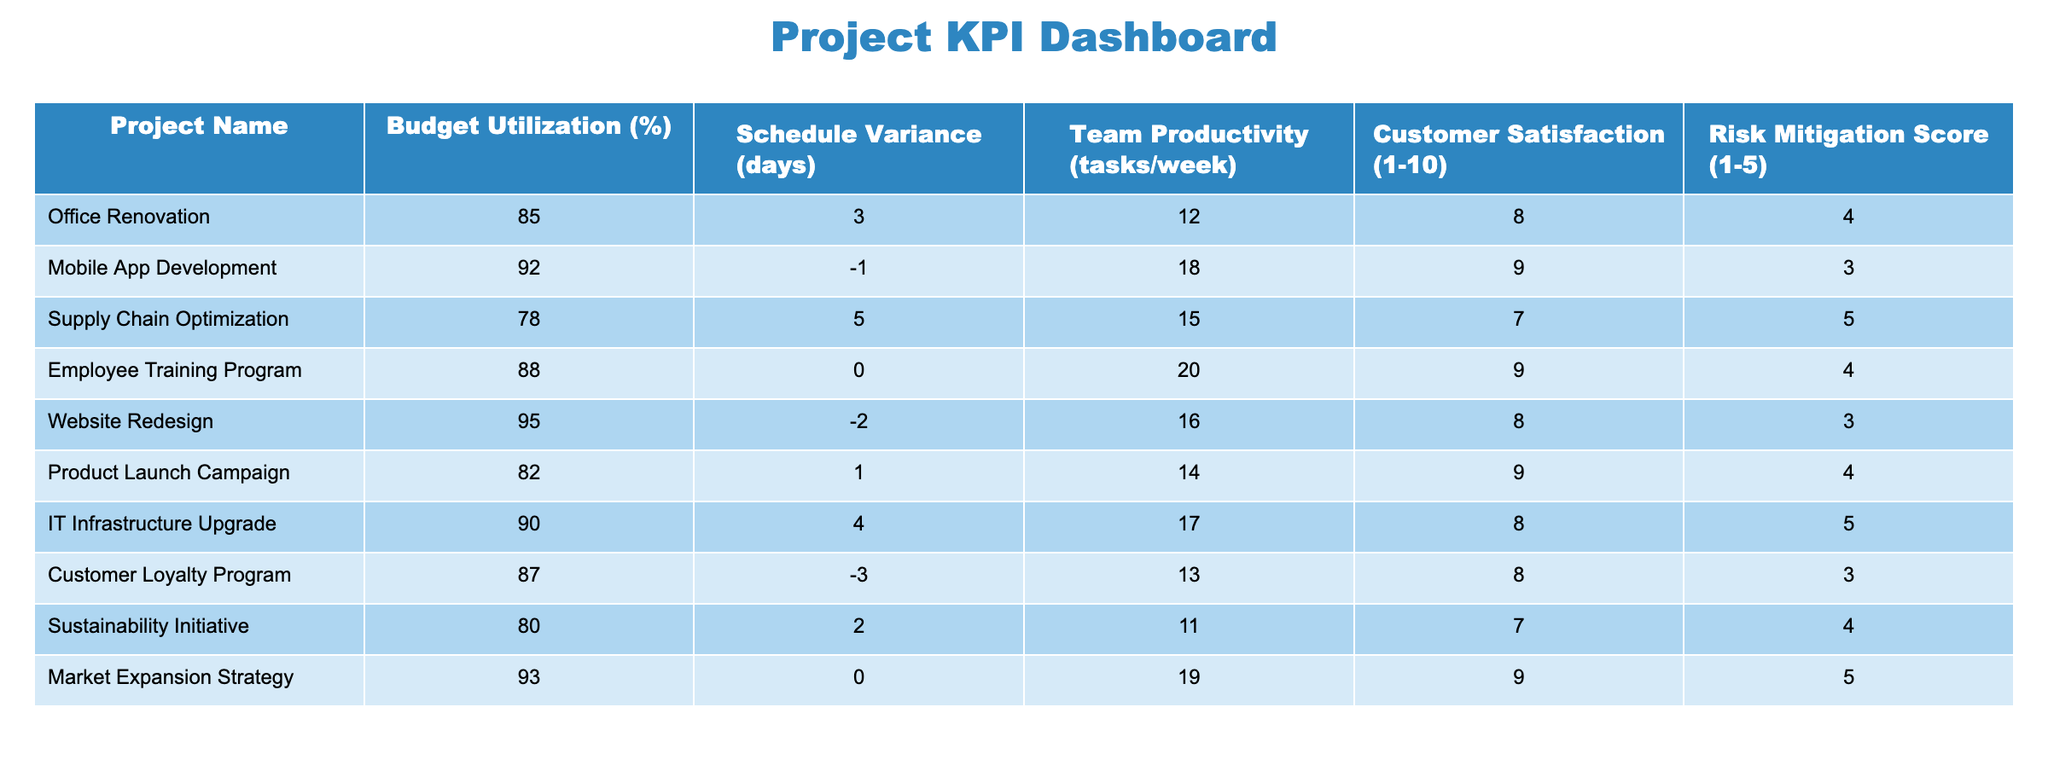What is the budget utilization percentage of the Mobile App Development project? The table shows the budget utilization percentage for each project. For the Mobile App Development project, the value listed in the corresponding row is 92%.
Answer: 92% Which project has the highest customer satisfaction rating? The customer satisfaction ratings are given on a scale from 1 to 10 for each project. By scanning the table, the highest rating is found under Mobile App Development, which is 9.
Answer: Mobile App Development What is the average team productivity for all projects? The team productivity values for the projects are 12, 18, 15, 20, 16, 14, 17, 13, 11, and 19. To find the average, sum these numbers (12 + 18 + 15 + 20 + 16 + 14 + 17 + 13 + 11 + 19 =  15.5) and divide by the number of projects (10), resulting in 15.5.
Answer: 15.5 Is the schedule variance for the Supply Chain Optimization project positive? The schedule variance for the Supply Chain Optimization project is listed as +5 days in the table. A positive value indicates that the project is ahead of schedule.
Answer: Yes Which project exhibits the lowest risk mitigation score? Each project's risk mitigation score ranges from 1 to 5. By examining the table, the project with the lowest risk mitigation score is Customer Loyalty Program, which has a score of 3.
Answer: Customer Loyalty Program How many projects have a budget utilization percentage of 90% or above? By reviewing the budget utilization percentages, we see that the projects with 90% or higher are Mobile App Development (92%), IT Infrastructure Upgrade (90%), and Website Redesign (95%). That totals to three projects.
Answer: 3 Which project has the highest schedule variance and what is that variance? Looking at the schedule variance values, the highest is +5 days under the Supply Chain Optimization project. Therefore, this project has the highest schedule variance.
Answer: Supply Chain Optimization, +5 days Are there any projects with a customer satisfaction rating below 8? By examining the table, the projects with customer satisfaction ratings below 8 are Supply Chain Optimization (7), Website Redesign (8), and Customer Loyalty Program (8). So yes, there are projects with ratings below 8.
Answer: Yes What is the total risk mitigation score of the projects that have a budget utilization below 85%? The projects with a budget utilization below 85% are Office Renovation (4) and Supply Chain Optimization (5). Adding their risk mitigation scores gives us 4 + 5 = 9.
Answer: 9 